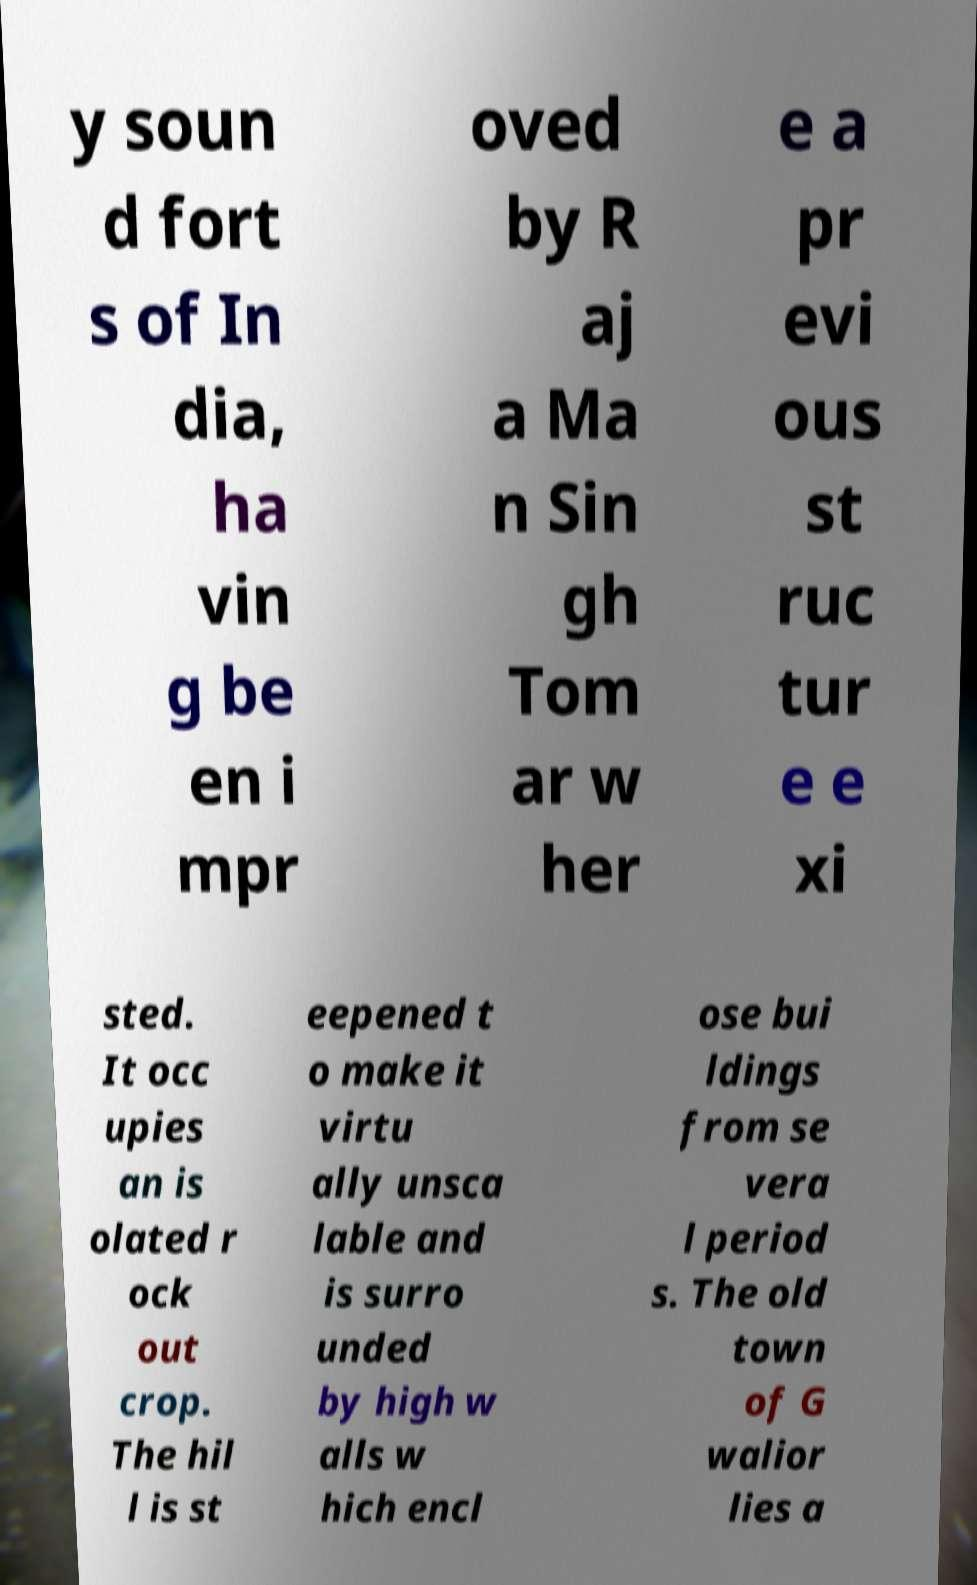Can you accurately transcribe the text from the provided image for me? y soun d fort s of In dia, ha vin g be en i mpr oved by R aj a Ma n Sin gh Tom ar w her e a pr evi ous st ruc tur e e xi sted. It occ upies an is olated r ock out crop. The hil l is st eepened t o make it virtu ally unsca lable and is surro unded by high w alls w hich encl ose bui ldings from se vera l period s. The old town of G walior lies a 